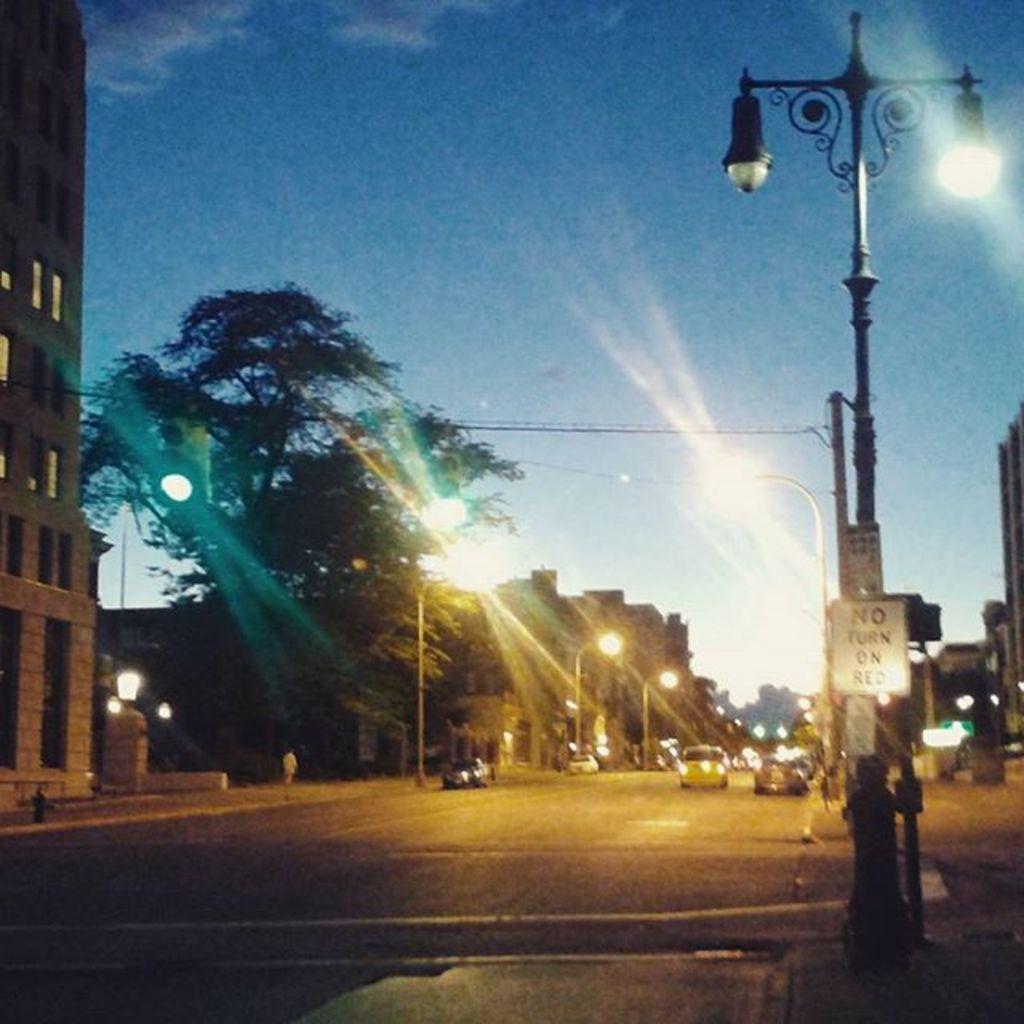Describe this image in one or two sentences. In the image there are few cars going on the road with street lights on either side of it followed by trees and buildings on the left side, and above its sky. 